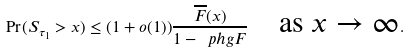Convert formula to latex. <formula><loc_0><loc_0><loc_500><loc_500>\Pr ( S _ { \tau _ { 1 } } > x ) \leq ( 1 + o ( 1 ) ) \frac { \overline { F } ( x ) } { 1 - \ p h g { F } } \quad \text {as $x\to\infty$} .</formula> 